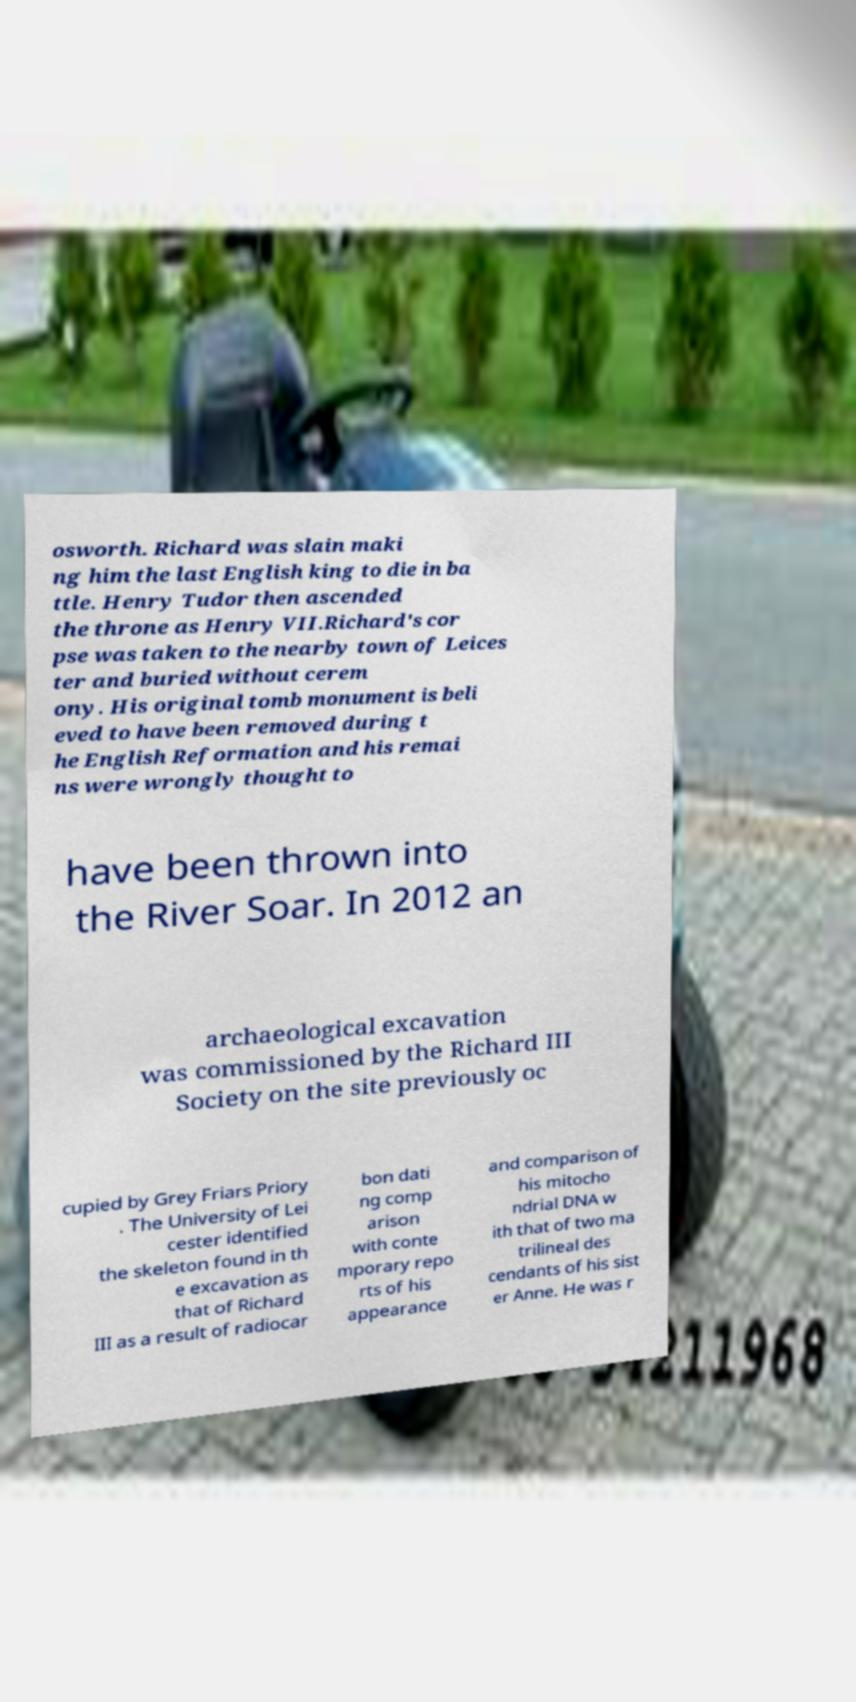For documentation purposes, I need the text within this image transcribed. Could you provide that? osworth. Richard was slain maki ng him the last English king to die in ba ttle. Henry Tudor then ascended the throne as Henry VII.Richard's cor pse was taken to the nearby town of Leices ter and buried without cerem ony. His original tomb monument is beli eved to have been removed during t he English Reformation and his remai ns were wrongly thought to have been thrown into the River Soar. In 2012 an archaeological excavation was commissioned by the Richard III Society on the site previously oc cupied by Grey Friars Priory . The University of Lei cester identified the skeleton found in th e excavation as that of Richard III as a result of radiocar bon dati ng comp arison with conte mporary repo rts of his appearance and comparison of his mitocho ndrial DNA w ith that of two ma trilineal des cendants of his sist er Anne. He was r 